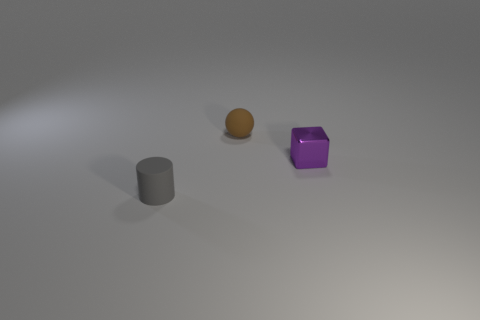What material is the small object that is to the right of the small rubber ball that is on the left side of the object that is right of the small brown ball made of?
Offer a terse response. Metal. Are there an equal number of tiny matte balls to the right of the tiny brown matte sphere and big green matte cylinders?
Provide a succinct answer. Yes. Does the object that is right of the brown rubber thing have the same material as the tiny cylinder to the left of the tiny brown rubber sphere?
Offer a very short reply. No. Is there any other thing that is the same material as the purple object?
Provide a succinct answer. No. Are there fewer tiny brown spheres behind the tiny matte sphere than large red metal spheres?
Give a very brief answer. No. There is a rubber object that is in front of the purple block; what is its size?
Make the answer very short. Small. The tiny matte thing in front of the tiny brown ball that is behind the thing to the right of the brown object is what shape?
Offer a very short reply. Cylinder. There is a small thing that is on the left side of the metal object and on the right side of the cylinder; what is its shape?
Offer a terse response. Sphere. Are there any objects that have the same size as the cube?
Your answer should be compact. Yes. Is there a large gray rubber thing of the same shape as the brown matte object?
Your answer should be compact. No. 